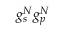<formula> <loc_0><loc_0><loc_500><loc_500>g _ { s } ^ { N } g _ { p } ^ { N }</formula> 